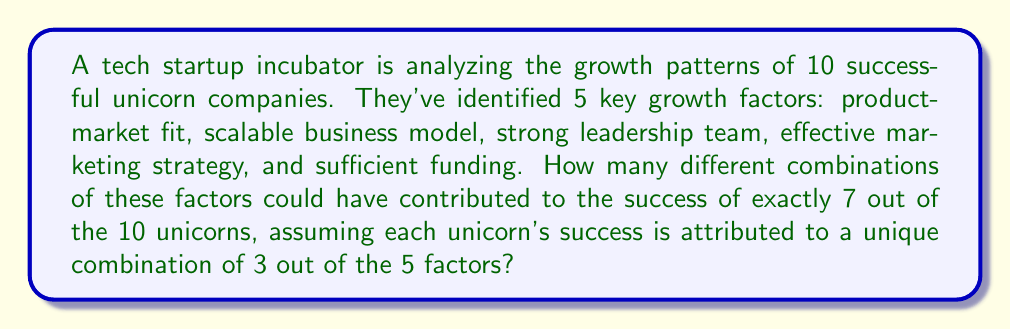What is the answer to this math problem? Let's break this down step-by-step:

1) First, we need to choose 7 unicorns out of 10. This can be done in $\binom{10}{7}$ ways.

2) For each of these 7 unicorns, we need to choose 3 factors out of 5. This can be done in $\binom{5}{3}$ ways.

3) For the remaining 3 unicorns, we need to ensure they have a different combination of factors. We can achieve this by choosing 3 factors out of 5 in $\binom{5}{3}$ ways, but we need to subtract the combination used by the 7 successful unicorns. So, for each of these 3 unicorns, we have $\binom{5}{3} - 1$ choices.

4) Now, let's put it all together using the multiplication principle:

   $$\binom{10}{7} \cdot \binom{5}{3} \cdot (\binom{5}{3} - 1)^3$$

5) Let's calculate each part:
   $\binom{10}{7} = 120$
   $\binom{5}{3} = 10$
   $\binom{5}{3} - 1 = 9$

6) Substituting these values:

   $$120 \cdot 10 \cdot 9^3 = 120 \cdot 10 \cdot 729 = 874,800$$

Therefore, there are 874,800 different combinations of growth factors that could have contributed to the success of exactly 7 out of the 10 unicorns.
Answer: 874,800 